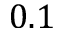<formula> <loc_0><loc_0><loc_500><loc_500>0 . 1</formula> 